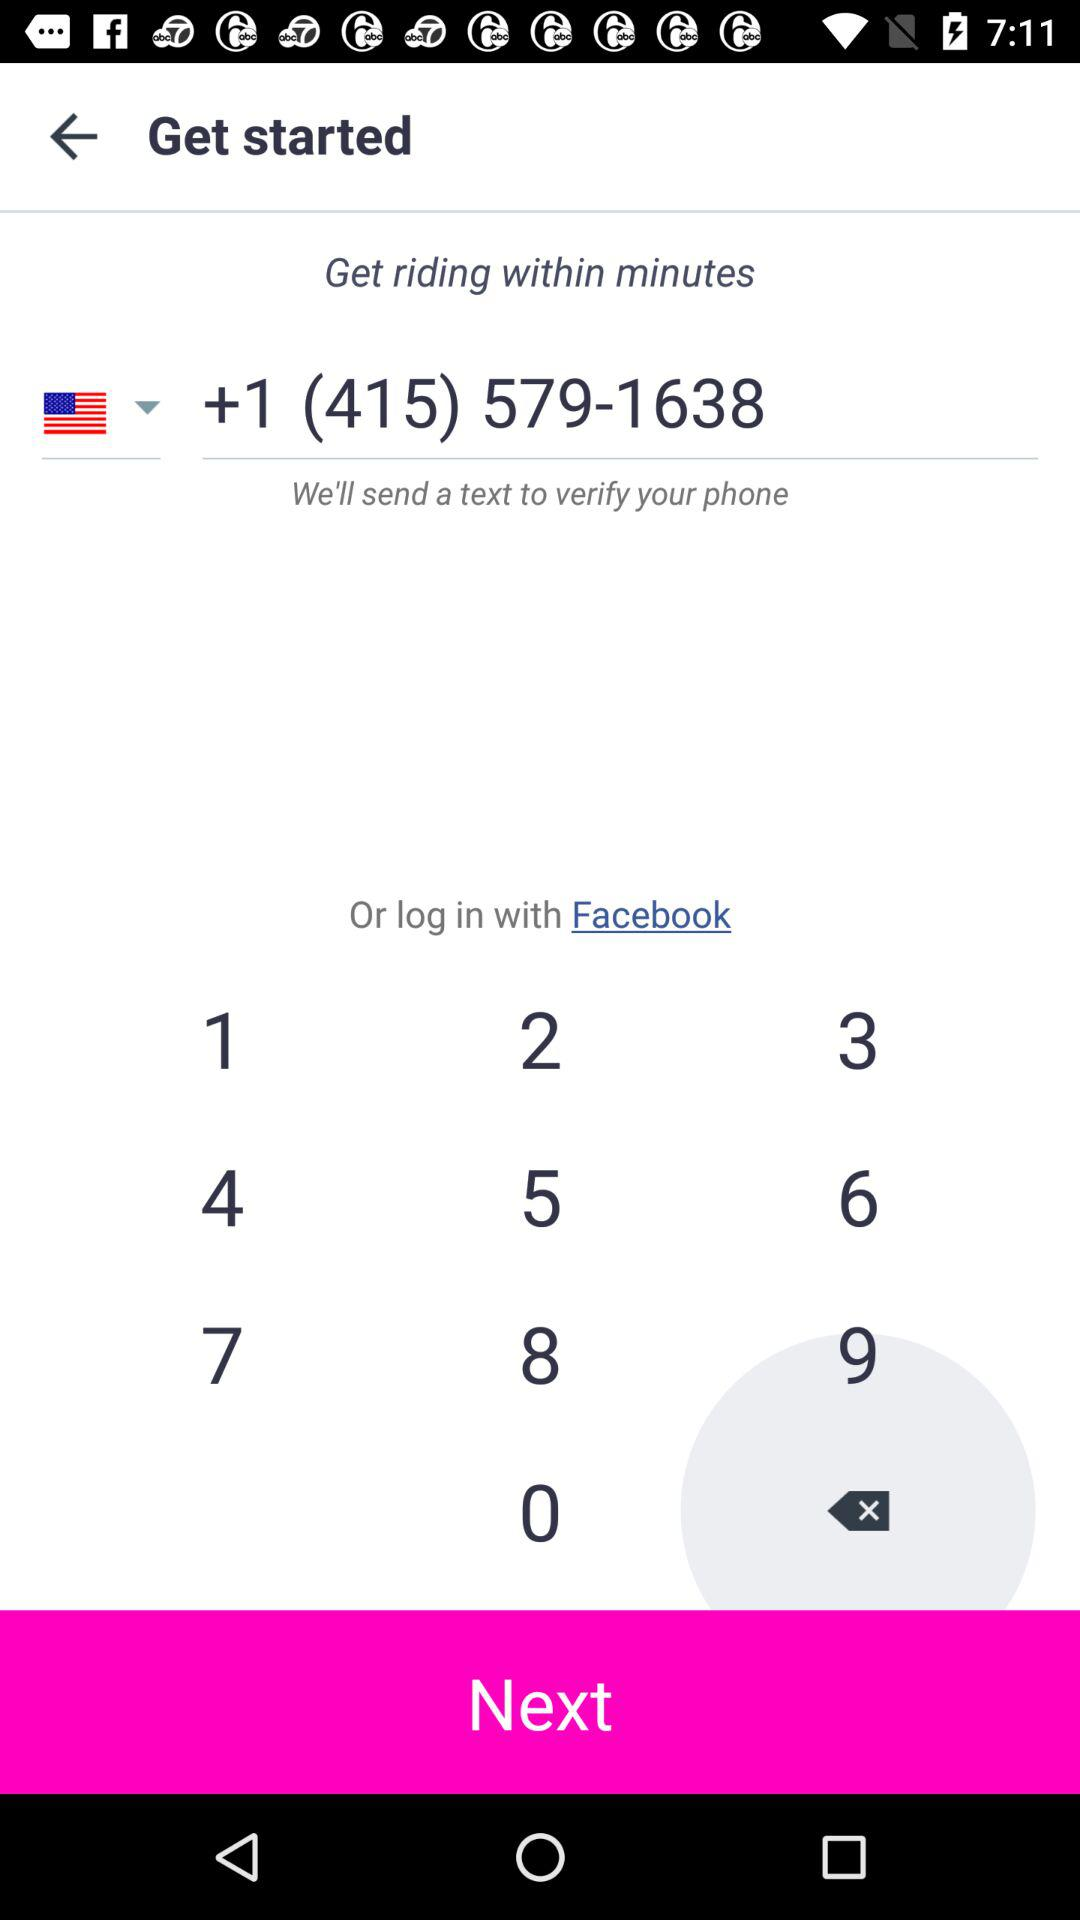What application can be used for logging in? The application that can be used for logging in is "Facebook". 